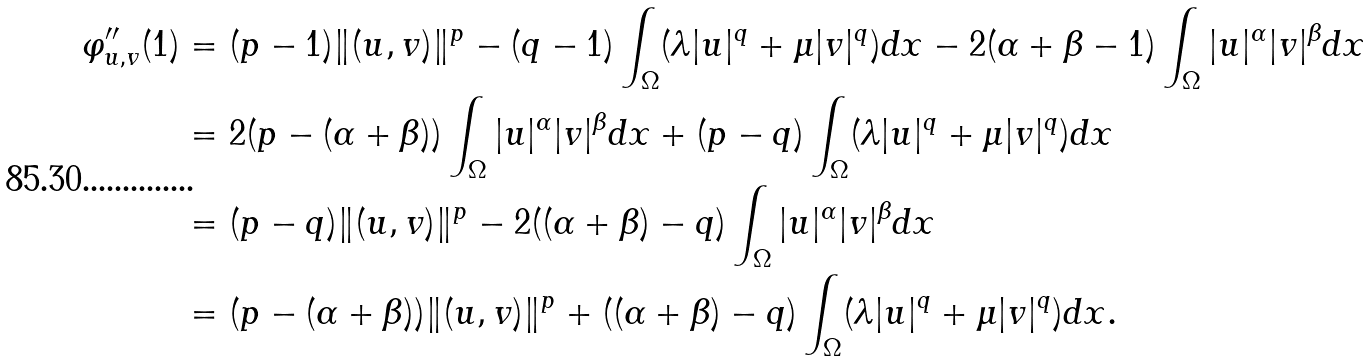Convert formula to latex. <formula><loc_0><loc_0><loc_500><loc_500>\varphi _ { u , v } ^ { \prime \prime } ( 1 ) & = ( p - 1 ) \| ( u , v ) \| ^ { p } - ( q - 1 ) \int _ { \Omega } ( \lambda | u | ^ { q } + \mu | v | ^ { q } ) d x - 2 ( \alpha + \beta - 1 ) \int _ { \Omega } | u | ^ { \alpha } | v | ^ { \beta } d x \\ & = 2 ( p - ( \alpha + \beta ) ) \int _ { \Omega } | u | ^ { \alpha } | v | ^ { \beta } d x + ( p - q ) \int _ { \Omega } ( \lambda | u | ^ { q } + \mu | v | ^ { q } ) d x \\ & = ( p - q ) \| ( u , v ) \| ^ { p } - 2 ( ( \alpha + \beta ) - q ) \int _ { \Omega } | u | ^ { \alpha } | v | ^ { \beta } d x \\ & = ( p - ( \alpha + \beta ) ) \| ( u , v ) \| ^ { p } + ( ( \alpha + \beta ) - q ) \int _ { \Omega } ( \lambda | u | ^ { q } + \mu | v | ^ { q } ) d x .</formula> 